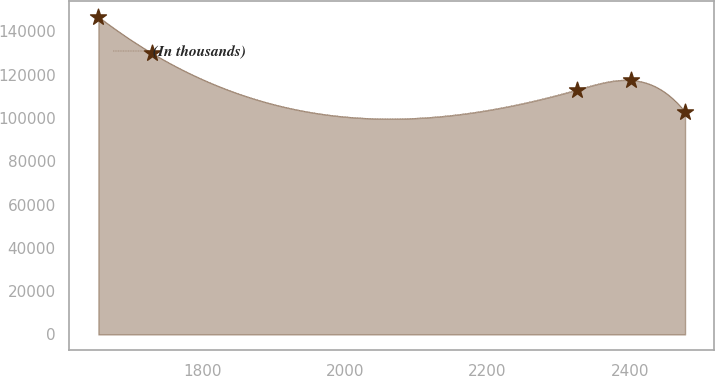Convert chart to OTSL. <chart><loc_0><loc_0><loc_500><loc_500><line_chart><ecel><fcel>(In thousands)<nl><fcel>1654.36<fcel>146719<nl><fcel>1729.98<fcel>129823<nl><fcel>2325.95<fcel>113057<nl><fcel>2401.57<fcel>117448<nl><fcel>2477.19<fcel>102807<nl></chart> 